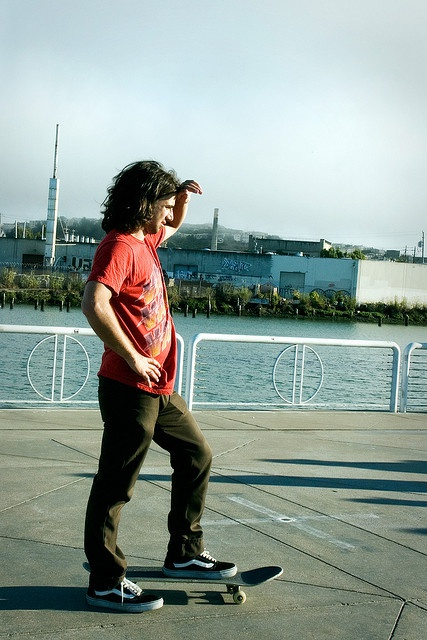Describe the objects in this image and their specific colors. I can see people in lightblue, black, darkgray, ivory, and maroon tones and skateboard in lightblue, black, teal, and darkgreen tones in this image. 